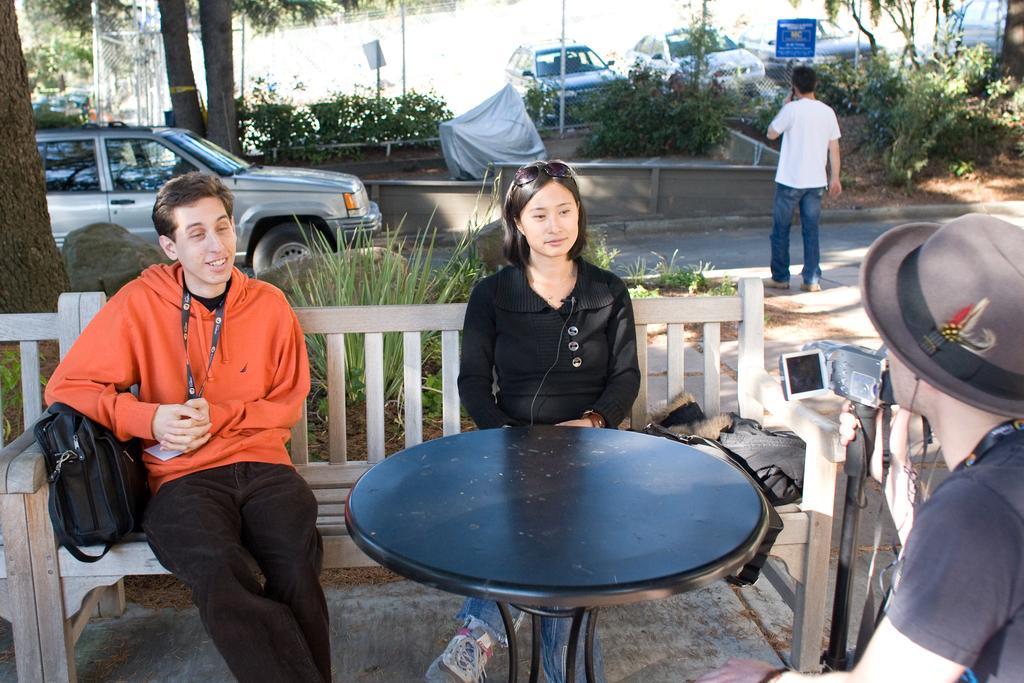Please provide a concise description of this image. In this picture there are two people sitting on a wooden chair and a black stool in front of them and a guy who is catching a camera is clicking them. In the background we observe a car and a man standing on the road, there are also few cars and plants in the background. 